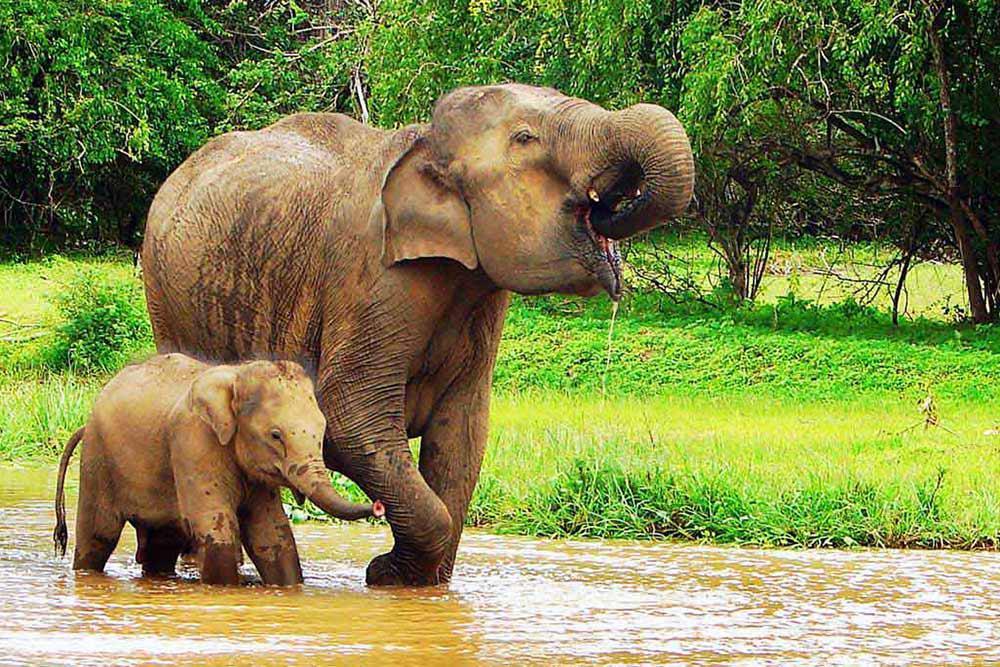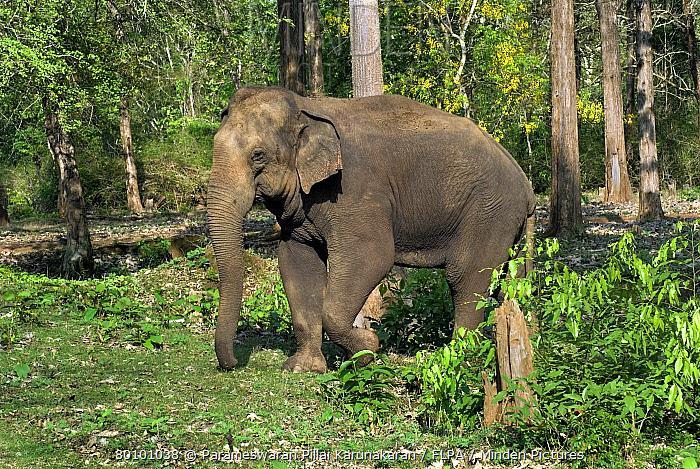The first image is the image on the left, the second image is the image on the right. Examine the images to the left and right. Is the description "In the right image the elephant has tusks" accurate? Answer yes or no. No. The first image is the image on the left, the second image is the image on the right. Analyze the images presented: Is the assertion "The left image contains a baby elephant with an adult" valid? Answer yes or no. Yes. 